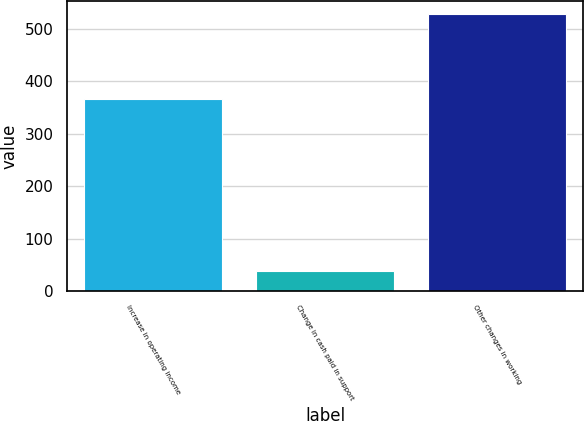Convert chart to OTSL. <chart><loc_0><loc_0><loc_500><loc_500><bar_chart><fcel>Increase in operating income<fcel>Change in cash paid in support<fcel>Other changes in working<nl><fcel>365<fcel>39<fcel>527<nl></chart> 